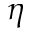Convert formula to latex. <formula><loc_0><loc_0><loc_500><loc_500>\eta</formula> 